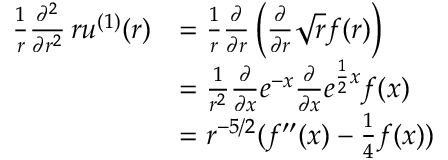<formula> <loc_0><loc_0><loc_500><loc_500>\begin{array} { r l } { \frac { 1 } { r } \frac { \partial ^ { 2 } } { \partial r ^ { 2 } } \, r u ^ { ( 1 ) } ( r ) } & { = \frac { 1 } { r } \frac { \partial } { \partial r } \left ( \frac { \partial } { \partial r } \sqrt { r } f ( r ) \right ) } \\ & { = \frac { 1 } { r ^ { 2 } } \frac { \partial } { \partial x } e ^ { - x } \frac { \partial } { \partial x } e ^ { \frac { 1 } { 2 } x } f ( x ) } \\ & { = r ^ { - 5 / 2 } ( f ^ { \prime \prime } ( x ) - \frac { 1 } { 4 } f ( x ) ) } \end{array}</formula> 